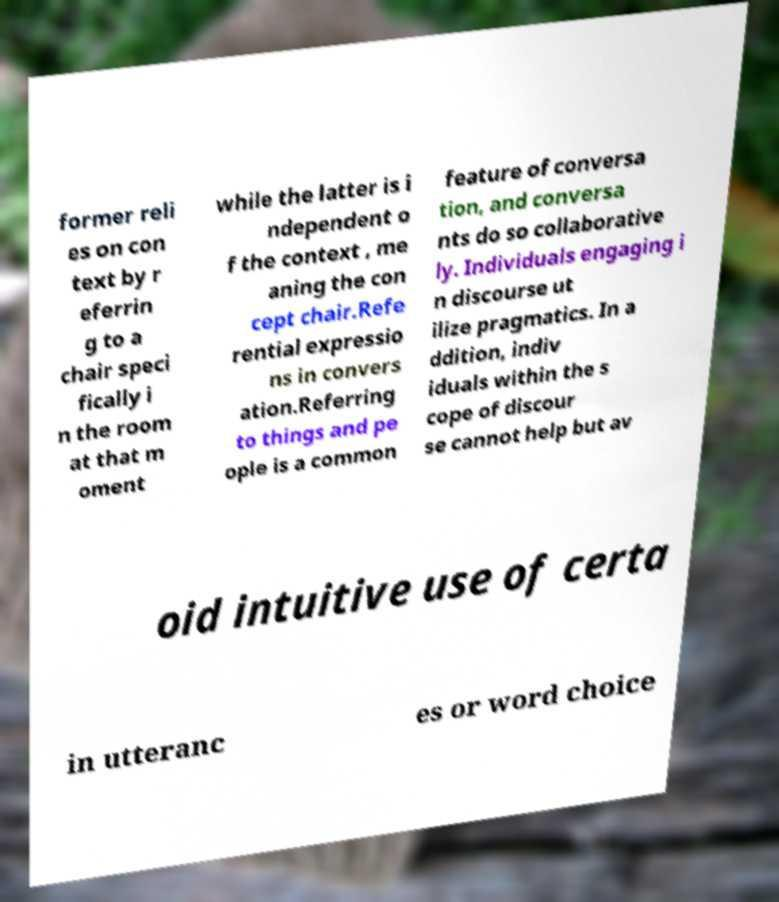Could you assist in decoding the text presented in this image and type it out clearly? former reli es on con text by r eferrin g to a chair speci fically i n the room at that m oment while the latter is i ndependent o f the context , me aning the con cept chair.Refe rential expressio ns in convers ation.Referring to things and pe ople is a common feature of conversa tion, and conversa nts do so collaborative ly. Individuals engaging i n discourse ut ilize pragmatics. In a ddition, indiv iduals within the s cope of discour se cannot help but av oid intuitive use of certa in utteranc es or word choice 